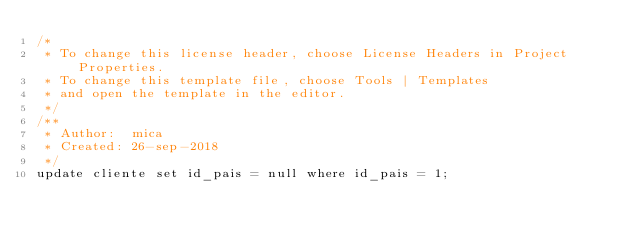<code> <loc_0><loc_0><loc_500><loc_500><_SQL_>/* 
 * To change this license header, choose License Headers in Project Properties.
 * To change this template file, choose Tools | Templates
 * and open the template in the editor.
 */
/**
 * Author:  mica
 * Created: 26-sep-2018
 */
update cliente set id_pais = null where id_pais = 1;
</code> 